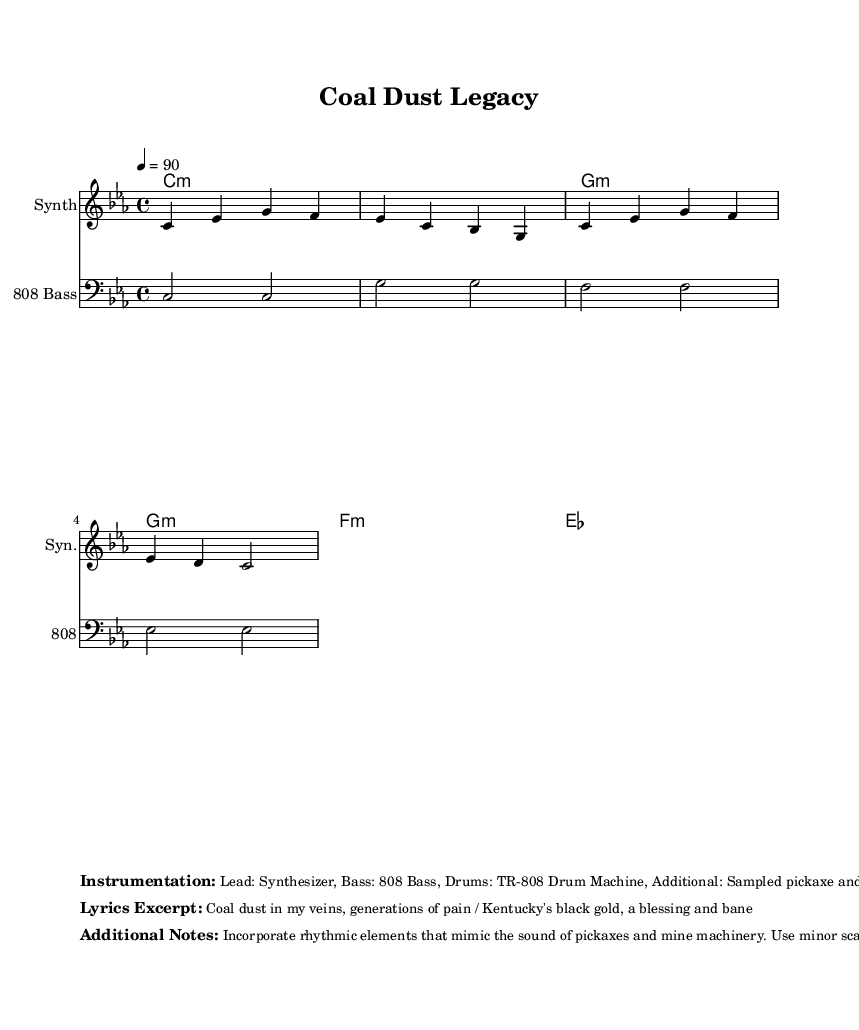What is the key signature of this music? The key signature is indicated at the beginning of the piece and shows C minor, which has three flats (B, E, A).
Answer: C minor What is the time signature of this music? The time signature is located right after the key signature in the sheet and is 4/4, meaning there are four beats per measure.
Answer: 4/4 What is the tempo marking for this piece? The tempo marking is noted in the score as "4 = 90," which indicates that there are 90 quarter note beats per minute.
Answer: 90 How many measures are in the melody line? The melody line has four measures, which can be counted in the notation provided in the first staff.
Answer: 4 What instrument is indicated for the bass line? The bass line is specified to be played on an "808 Bass," as noted in the staff header for that section of the music.
Answer: 808 Bass Which musical elements are suggested to evoke the atmosphere of mining towns? The score notes that rhythmic elements mimicking pickaxes and mine machinery sounds should be incorporated, along with the use of minor scales for somberness.
Answer: Rhythmic elements mimicking pickaxes and minor scales What is the lyrical theme reflected in the excerpt provided? The lyrical theme revolves around the struggles and heritage connected to coal mining in Kentucky, as indicated by phrases like "Coal dust in my veins" and "generations of pain."
Answer: Coal mining struggles 